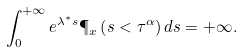Convert formula to latex. <formula><loc_0><loc_0><loc_500><loc_500>\int _ { 0 } ^ { + \infty } { e ^ { \lambda ^ { * } s } \P _ { x } \left ( s < \tau ^ { \alpha } \right ) d s } = + \infty .</formula> 